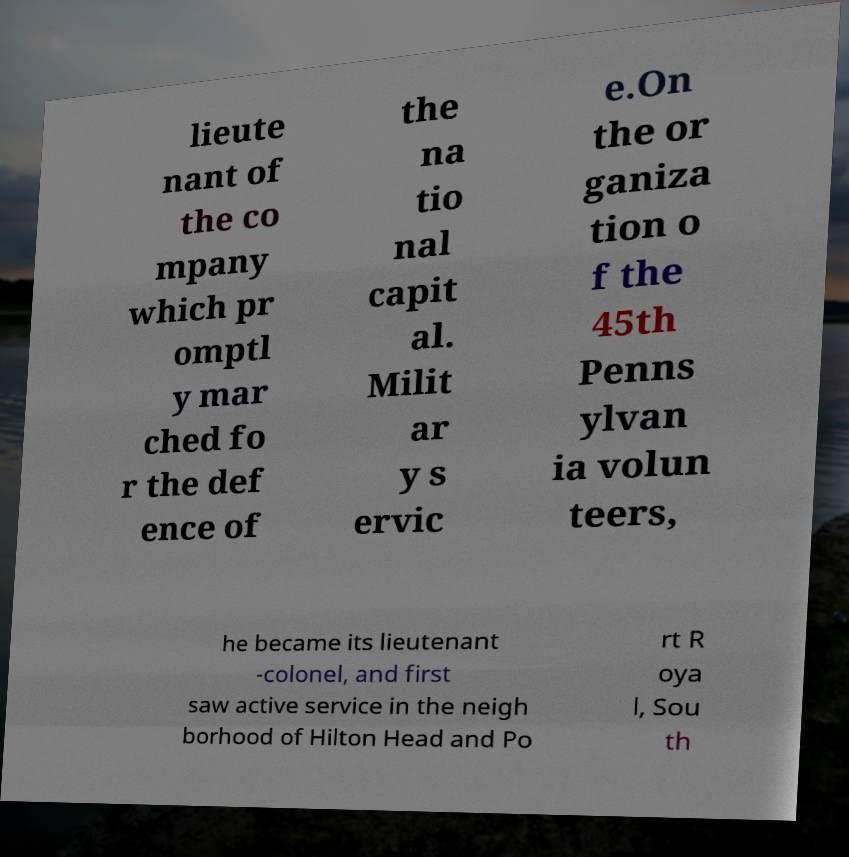I need the written content from this picture converted into text. Can you do that? lieute nant of the co mpany which pr omptl y mar ched fo r the def ence of the na tio nal capit al. Milit ar y s ervic e.On the or ganiza tion o f the 45th Penns ylvan ia volun teers, he became its lieutenant -colonel, and first saw active service in the neigh borhood of Hilton Head and Po rt R oya l, Sou th 